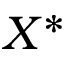<formula> <loc_0><loc_0><loc_500><loc_500>X ^ { * }</formula> 